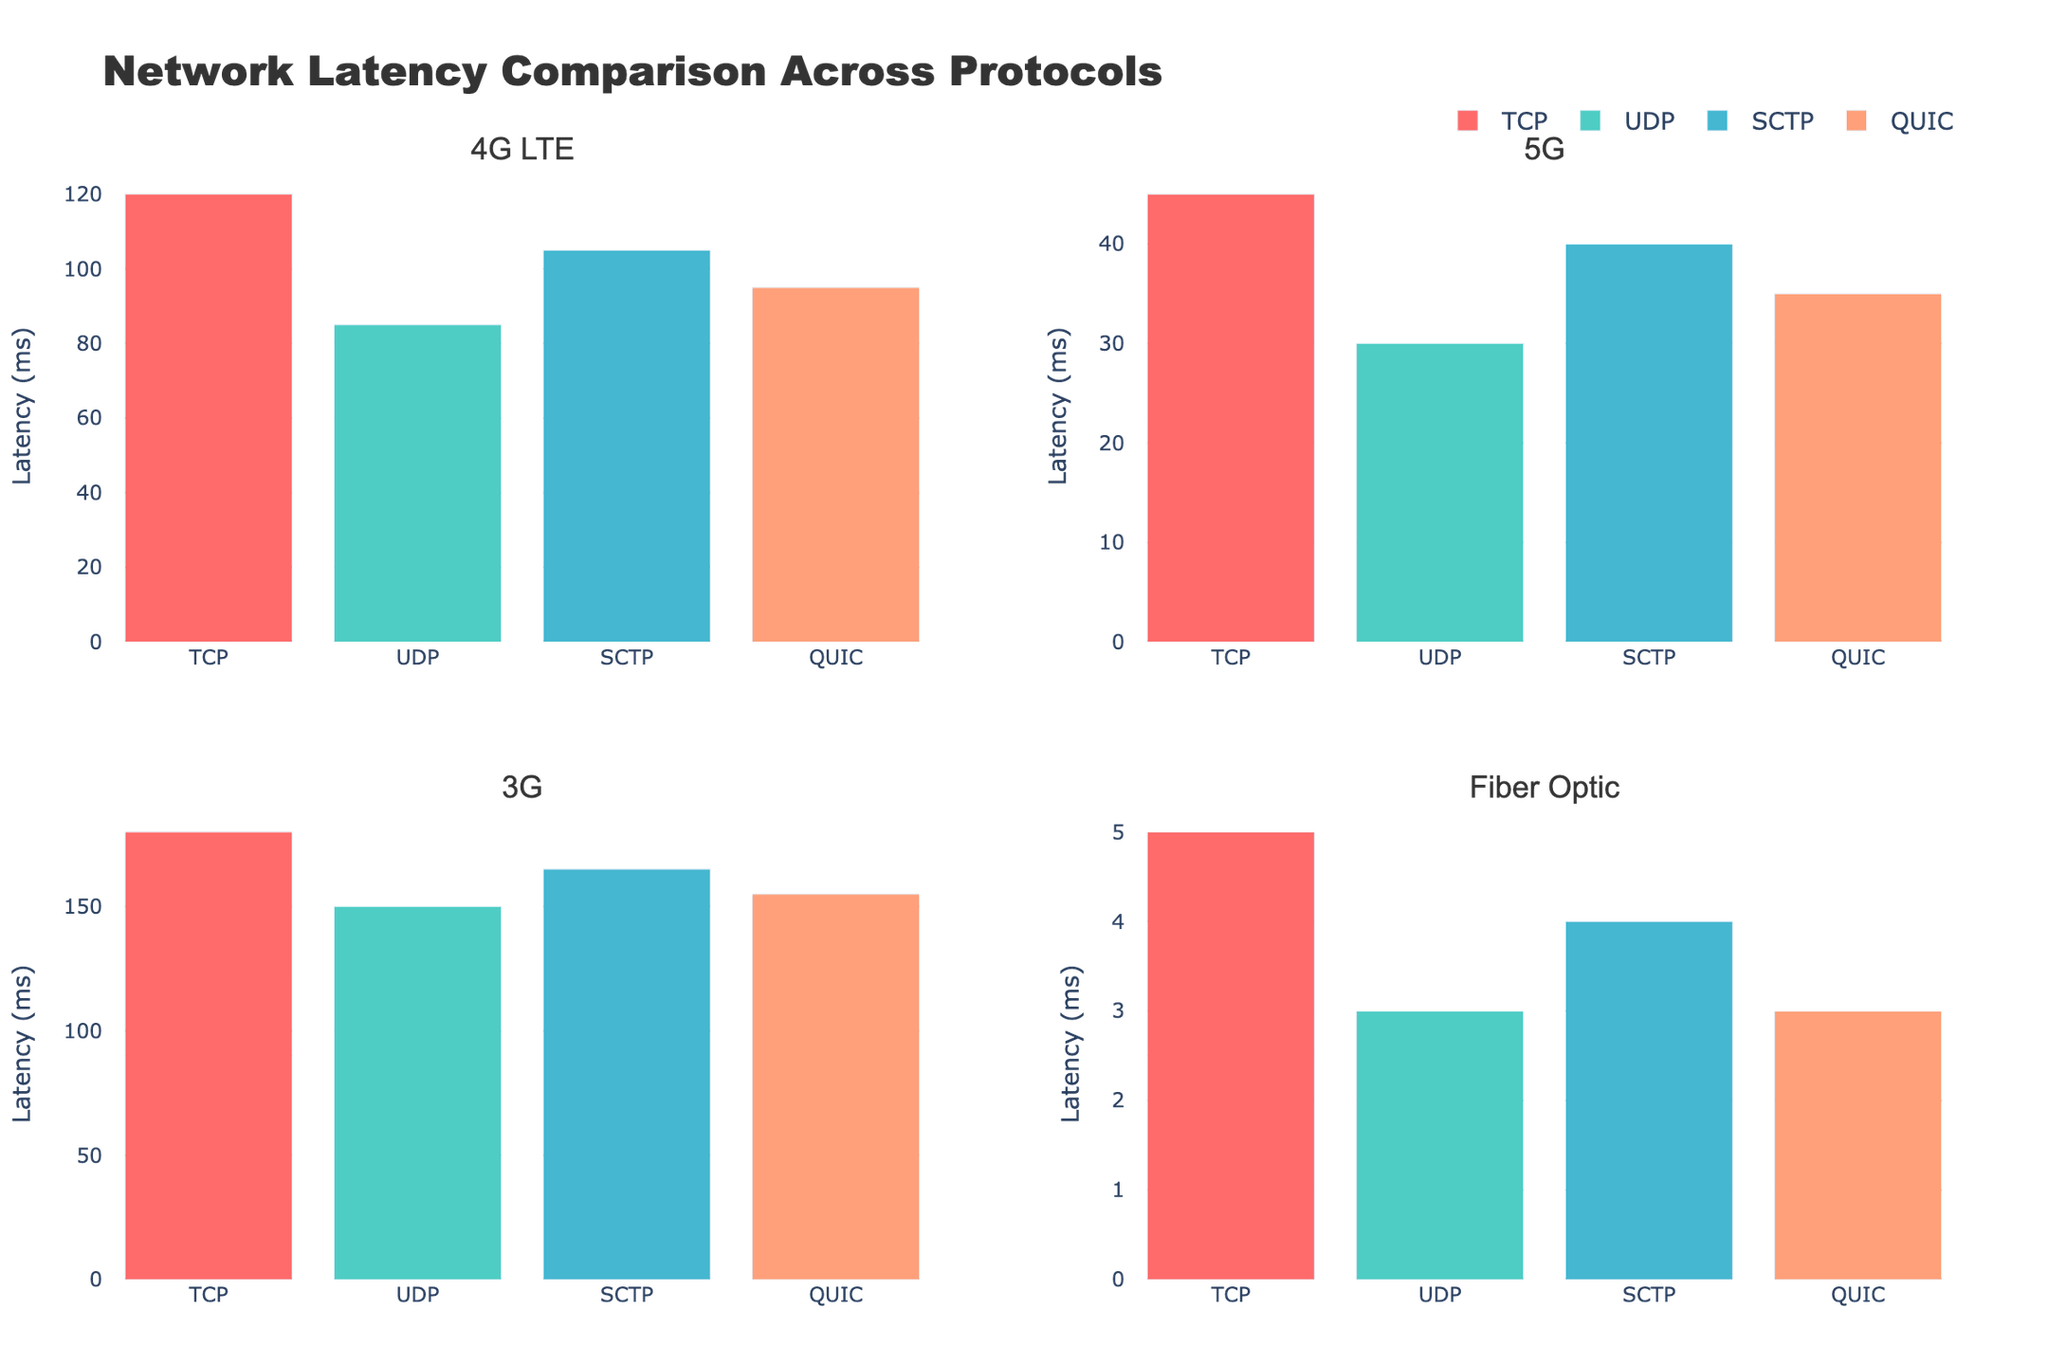What is the title of the figure? The title is usually placed at the top of the figure and describes the main topic or purpose of the visualization. In this case, the title is "Network Latency Comparison Across Protocols."
Answer: Network Latency Comparison Across Protocols Which protocol has the lowest latency on the 4G LTE network? To find the protocol with the lowest latency on the 4G LTE network, look at the bars in the subplot labeled "4G LTE" and compare their heights. The bar with the shortest height has the lowest latency, which corresponds to the UDP protocol.
Answer: UDP What is the average latency of the protocols on the 5G network? To calculate the average latency for the 5G network, sum the latencies of all protocols in the 5G subplot and divide by the number of protocols. The latencies are 45, 30, 40, and 35 ms, respectively. So, the average is (45+30+40+35)/4 = 37.5 ms.
Answer: 37.5 ms Which network type has the highest overall latency for each protocol? Compare the heights of the bars for each protocol across all subplots. The highest bar for each protocol indicates the network type with the highest latency for that protocol. For each protocol (TCP, UDP, SCTP, QUIC), the 3G network has the highest latency.
Answer: 3G What is the difference in latency between QUIC on the 4G LTE network and QUIC on the 5G network? Identify the latencies of QUIC on both the 4G LTE and 5G networks (95 ms and 35 ms, respectively) and subtract the latter from the former. 95 - 35 = 60 ms.
Answer: 60 ms On the Fiber Optic network, which protocols have the same latency? Examine the bars in the "Fiber Optic" subplot and identify protocols with equal bar heights. Both the UDP and QUIC protocols have a latency of 3 ms.
Answer: UDP and QUIC Which network type shows the most significant improvement in latency for TCP when switching from 4G LTE to 5G? Compare the latency of TCP in 4G LTE (120 ms) and 5G (45 ms). The improvement for 5G is calculated as 120 - 45 = 75 ms. Evaluate other network types to see if improvement exists but 4G LTE to 5G shows the most significant improvement.
Answer: 4G LTE What is the ratio of the highest latency to the lowest latency on the 3G network? Identify the highest latency on the 3G network (TCP, 180 ms) and the lowest (UDP, 150 ms), then divide the highest by the lowest. The ratio is 180/150 = 1.2.
Answer: 1.2 Which protocol maintains the most consistent latency across all network types? To find the most consistent protocol, look at the variance in latency values for each protocol across all network types. The UDP protocol shows relatively low variation, with latencies 85, 30, 150, and 3 ms across 4G LTE, 5G, 3G, and Fiber Optic networks respectively.
Answer: UDP 